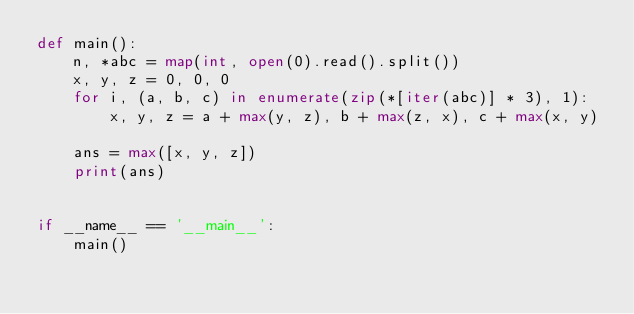Convert code to text. <code><loc_0><loc_0><loc_500><loc_500><_Python_>def main():
    n, *abc = map(int, open(0).read().split())
    x, y, z = 0, 0, 0
    for i, (a, b, c) in enumerate(zip(*[iter(abc)] * 3), 1):
        x, y, z = a + max(y, z), b + max(z, x), c + max(x, y)
    
    ans = max([x, y, z])
    print(ans)


if __name__ == '__main__':
    main()
</code> 